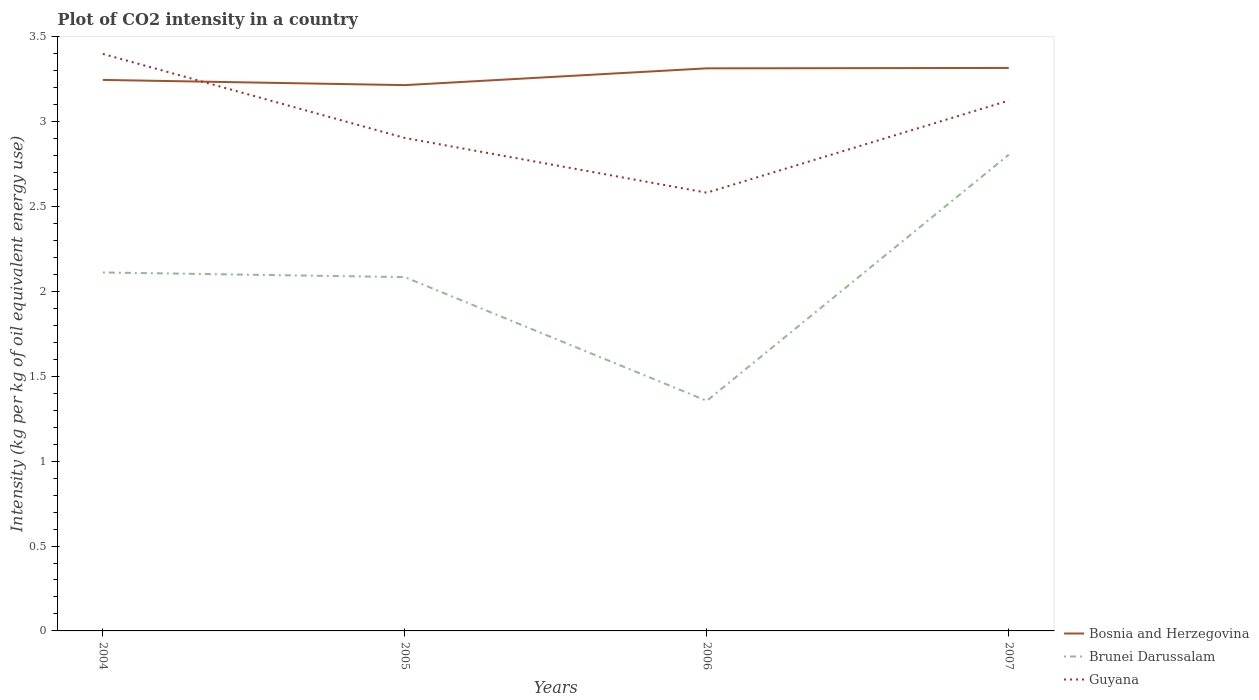How many different coloured lines are there?
Your answer should be compact. 3. Does the line corresponding to Brunei Darussalam intersect with the line corresponding to Bosnia and Herzegovina?
Provide a succinct answer. No. Is the number of lines equal to the number of legend labels?
Your answer should be compact. Yes. Across all years, what is the maximum CO2 intensity in in Brunei Darussalam?
Give a very brief answer. 1.36. What is the total CO2 intensity in in Guyana in the graph?
Offer a very short reply. 0.32. What is the difference between the highest and the second highest CO2 intensity in in Bosnia and Herzegovina?
Ensure brevity in your answer.  0.1. What is the difference between the highest and the lowest CO2 intensity in in Bosnia and Herzegovina?
Your answer should be very brief. 2. Does the graph contain any zero values?
Your response must be concise. No. Does the graph contain grids?
Make the answer very short. No. How many legend labels are there?
Offer a very short reply. 3. How are the legend labels stacked?
Offer a very short reply. Vertical. What is the title of the graph?
Give a very brief answer. Plot of CO2 intensity in a country. What is the label or title of the X-axis?
Offer a very short reply. Years. What is the label or title of the Y-axis?
Offer a terse response. Intensity (kg per kg of oil equivalent energy use). What is the Intensity (kg per kg of oil equivalent energy use) of Bosnia and Herzegovina in 2004?
Your answer should be compact. 3.25. What is the Intensity (kg per kg of oil equivalent energy use) of Brunei Darussalam in 2004?
Your answer should be compact. 2.11. What is the Intensity (kg per kg of oil equivalent energy use) in Guyana in 2004?
Provide a succinct answer. 3.4. What is the Intensity (kg per kg of oil equivalent energy use) of Bosnia and Herzegovina in 2005?
Offer a terse response. 3.22. What is the Intensity (kg per kg of oil equivalent energy use) in Brunei Darussalam in 2005?
Your answer should be compact. 2.08. What is the Intensity (kg per kg of oil equivalent energy use) in Guyana in 2005?
Offer a terse response. 2.9. What is the Intensity (kg per kg of oil equivalent energy use) of Bosnia and Herzegovina in 2006?
Provide a short and direct response. 3.31. What is the Intensity (kg per kg of oil equivalent energy use) of Brunei Darussalam in 2006?
Your answer should be very brief. 1.36. What is the Intensity (kg per kg of oil equivalent energy use) in Guyana in 2006?
Give a very brief answer. 2.58. What is the Intensity (kg per kg of oil equivalent energy use) in Bosnia and Herzegovina in 2007?
Your response must be concise. 3.32. What is the Intensity (kg per kg of oil equivalent energy use) of Brunei Darussalam in 2007?
Ensure brevity in your answer.  2.81. What is the Intensity (kg per kg of oil equivalent energy use) in Guyana in 2007?
Your answer should be very brief. 3.12. Across all years, what is the maximum Intensity (kg per kg of oil equivalent energy use) in Bosnia and Herzegovina?
Provide a short and direct response. 3.32. Across all years, what is the maximum Intensity (kg per kg of oil equivalent energy use) of Brunei Darussalam?
Make the answer very short. 2.81. Across all years, what is the maximum Intensity (kg per kg of oil equivalent energy use) of Guyana?
Your response must be concise. 3.4. Across all years, what is the minimum Intensity (kg per kg of oil equivalent energy use) of Bosnia and Herzegovina?
Give a very brief answer. 3.22. Across all years, what is the minimum Intensity (kg per kg of oil equivalent energy use) in Brunei Darussalam?
Keep it short and to the point. 1.36. Across all years, what is the minimum Intensity (kg per kg of oil equivalent energy use) in Guyana?
Give a very brief answer. 2.58. What is the total Intensity (kg per kg of oil equivalent energy use) of Bosnia and Herzegovina in the graph?
Provide a succinct answer. 13.09. What is the total Intensity (kg per kg of oil equivalent energy use) in Brunei Darussalam in the graph?
Your response must be concise. 8.36. What is the total Intensity (kg per kg of oil equivalent energy use) of Guyana in the graph?
Your response must be concise. 12.01. What is the difference between the Intensity (kg per kg of oil equivalent energy use) in Bosnia and Herzegovina in 2004 and that in 2005?
Keep it short and to the point. 0.03. What is the difference between the Intensity (kg per kg of oil equivalent energy use) in Brunei Darussalam in 2004 and that in 2005?
Make the answer very short. 0.03. What is the difference between the Intensity (kg per kg of oil equivalent energy use) of Guyana in 2004 and that in 2005?
Offer a terse response. 0.5. What is the difference between the Intensity (kg per kg of oil equivalent energy use) in Bosnia and Herzegovina in 2004 and that in 2006?
Your answer should be compact. -0.07. What is the difference between the Intensity (kg per kg of oil equivalent energy use) of Brunei Darussalam in 2004 and that in 2006?
Provide a short and direct response. 0.76. What is the difference between the Intensity (kg per kg of oil equivalent energy use) in Guyana in 2004 and that in 2006?
Provide a short and direct response. 0.82. What is the difference between the Intensity (kg per kg of oil equivalent energy use) of Bosnia and Herzegovina in 2004 and that in 2007?
Provide a succinct answer. -0.07. What is the difference between the Intensity (kg per kg of oil equivalent energy use) of Brunei Darussalam in 2004 and that in 2007?
Provide a succinct answer. -0.69. What is the difference between the Intensity (kg per kg of oil equivalent energy use) of Guyana in 2004 and that in 2007?
Give a very brief answer. 0.27. What is the difference between the Intensity (kg per kg of oil equivalent energy use) in Bosnia and Herzegovina in 2005 and that in 2006?
Your answer should be very brief. -0.1. What is the difference between the Intensity (kg per kg of oil equivalent energy use) in Brunei Darussalam in 2005 and that in 2006?
Offer a terse response. 0.73. What is the difference between the Intensity (kg per kg of oil equivalent energy use) in Guyana in 2005 and that in 2006?
Give a very brief answer. 0.32. What is the difference between the Intensity (kg per kg of oil equivalent energy use) in Bosnia and Herzegovina in 2005 and that in 2007?
Your response must be concise. -0.1. What is the difference between the Intensity (kg per kg of oil equivalent energy use) in Brunei Darussalam in 2005 and that in 2007?
Provide a short and direct response. -0.72. What is the difference between the Intensity (kg per kg of oil equivalent energy use) in Guyana in 2005 and that in 2007?
Keep it short and to the point. -0.22. What is the difference between the Intensity (kg per kg of oil equivalent energy use) of Bosnia and Herzegovina in 2006 and that in 2007?
Offer a very short reply. -0. What is the difference between the Intensity (kg per kg of oil equivalent energy use) in Brunei Darussalam in 2006 and that in 2007?
Offer a very short reply. -1.45. What is the difference between the Intensity (kg per kg of oil equivalent energy use) of Guyana in 2006 and that in 2007?
Ensure brevity in your answer.  -0.54. What is the difference between the Intensity (kg per kg of oil equivalent energy use) in Bosnia and Herzegovina in 2004 and the Intensity (kg per kg of oil equivalent energy use) in Brunei Darussalam in 2005?
Provide a short and direct response. 1.16. What is the difference between the Intensity (kg per kg of oil equivalent energy use) of Bosnia and Herzegovina in 2004 and the Intensity (kg per kg of oil equivalent energy use) of Guyana in 2005?
Offer a very short reply. 0.34. What is the difference between the Intensity (kg per kg of oil equivalent energy use) in Brunei Darussalam in 2004 and the Intensity (kg per kg of oil equivalent energy use) in Guyana in 2005?
Ensure brevity in your answer.  -0.79. What is the difference between the Intensity (kg per kg of oil equivalent energy use) in Bosnia and Herzegovina in 2004 and the Intensity (kg per kg of oil equivalent energy use) in Brunei Darussalam in 2006?
Give a very brief answer. 1.89. What is the difference between the Intensity (kg per kg of oil equivalent energy use) of Bosnia and Herzegovina in 2004 and the Intensity (kg per kg of oil equivalent energy use) of Guyana in 2006?
Keep it short and to the point. 0.66. What is the difference between the Intensity (kg per kg of oil equivalent energy use) in Brunei Darussalam in 2004 and the Intensity (kg per kg of oil equivalent energy use) in Guyana in 2006?
Your response must be concise. -0.47. What is the difference between the Intensity (kg per kg of oil equivalent energy use) of Bosnia and Herzegovina in 2004 and the Intensity (kg per kg of oil equivalent energy use) of Brunei Darussalam in 2007?
Give a very brief answer. 0.44. What is the difference between the Intensity (kg per kg of oil equivalent energy use) of Bosnia and Herzegovina in 2004 and the Intensity (kg per kg of oil equivalent energy use) of Guyana in 2007?
Your answer should be compact. 0.12. What is the difference between the Intensity (kg per kg of oil equivalent energy use) of Brunei Darussalam in 2004 and the Intensity (kg per kg of oil equivalent energy use) of Guyana in 2007?
Make the answer very short. -1.01. What is the difference between the Intensity (kg per kg of oil equivalent energy use) in Bosnia and Herzegovina in 2005 and the Intensity (kg per kg of oil equivalent energy use) in Brunei Darussalam in 2006?
Give a very brief answer. 1.86. What is the difference between the Intensity (kg per kg of oil equivalent energy use) of Bosnia and Herzegovina in 2005 and the Intensity (kg per kg of oil equivalent energy use) of Guyana in 2006?
Your answer should be very brief. 0.63. What is the difference between the Intensity (kg per kg of oil equivalent energy use) in Brunei Darussalam in 2005 and the Intensity (kg per kg of oil equivalent energy use) in Guyana in 2006?
Ensure brevity in your answer.  -0.5. What is the difference between the Intensity (kg per kg of oil equivalent energy use) in Bosnia and Herzegovina in 2005 and the Intensity (kg per kg of oil equivalent energy use) in Brunei Darussalam in 2007?
Provide a short and direct response. 0.41. What is the difference between the Intensity (kg per kg of oil equivalent energy use) in Bosnia and Herzegovina in 2005 and the Intensity (kg per kg of oil equivalent energy use) in Guyana in 2007?
Provide a short and direct response. 0.09. What is the difference between the Intensity (kg per kg of oil equivalent energy use) in Brunei Darussalam in 2005 and the Intensity (kg per kg of oil equivalent energy use) in Guyana in 2007?
Give a very brief answer. -1.04. What is the difference between the Intensity (kg per kg of oil equivalent energy use) of Bosnia and Herzegovina in 2006 and the Intensity (kg per kg of oil equivalent energy use) of Brunei Darussalam in 2007?
Make the answer very short. 0.51. What is the difference between the Intensity (kg per kg of oil equivalent energy use) of Bosnia and Herzegovina in 2006 and the Intensity (kg per kg of oil equivalent energy use) of Guyana in 2007?
Provide a short and direct response. 0.19. What is the difference between the Intensity (kg per kg of oil equivalent energy use) of Brunei Darussalam in 2006 and the Intensity (kg per kg of oil equivalent energy use) of Guyana in 2007?
Your answer should be very brief. -1.77. What is the average Intensity (kg per kg of oil equivalent energy use) of Bosnia and Herzegovina per year?
Your answer should be compact. 3.27. What is the average Intensity (kg per kg of oil equivalent energy use) in Brunei Darussalam per year?
Make the answer very short. 2.09. What is the average Intensity (kg per kg of oil equivalent energy use) in Guyana per year?
Offer a very short reply. 3. In the year 2004, what is the difference between the Intensity (kg per kg of oil equivalent energy use) of Bosnia and Herzegovina and Intensity (kg per kg of oil equivalent energy use) of Brunei Darussalam?
Your answer should be compact. 1.13. In the year 2004, what is the difference between the Intensity (kg per kg of oil equivalent energy use) of Bosnia and Herzegovina and Intensity (kg per kg of oil equivalent energy use) of Guyana?
Give a very brief answer. -0.15. In the year 2004, what is the difference between the Intensity (kg per kg of oil equivalent energy use) in Brunei Darussalam and Intensity (kg per kg of oil equivalent energy use) in Guyana?
Keep it short and to the point. -1.29. In the year 2005, what is the difference between the Intensity (kg per kg of oil equivalent energy use) in Bosnia and Herzegovina and Intensity (kg per kg of oil equivalent energy use) in Brunei Darussalam?
Keep it short and to the point. 1.13. In the year 2005, what is the difference between the Intensity (kg per kg of oil equivalent energy use) in Bosnia and Herzegovina and Intensity (kg per kg of oil equivalent energy use) in Guyana?
Your answer should be very brief. 0.31. In the year 2005, what is the difference between the Intensity (kg per kg of oil equivalent energy use) of Brunei Darussalam and Intensity (kg per kg of oil equivalent energy use) of Guyana?
Provide a short and direct response. -0.82. In the year 2006, what is the difference between the Intensity (kg per kg of oil equivalent energy use) of Bosnia and Herzegovina and Intensity (kg per kg of oil equivalent energy use) of Brunei Darussalam?
Your answer should be compact. 1.96. In the year 2006, what is the difference between the Intensity (kg per kg of oil equivalent energy use) in Bosnia and Herzegovina and Intensity (kg per kg of oil equivalent energy use) in Guyana?
Offer a very short reply. 0.73. In the year 2006, what is the difference between the Intensity (kg per kg of oil equivalent energy use) in Brunei Darussalam and Intensity (kg per kg of oil equivalent energy use) in Guyana?
Your response must be concise. -1.23. In the year 2007, what is the difference between the Intensity (kg per kg of oil equivalent energy use) in Bosnia and Herzegovina and Intensity (kg per kg of oil equivalent energy use) in Brunei Darussalam?
Your response must be concise. 0.51. In the year 2007, what is the difference between the Intensity (kg per kg of oil equivalent energy use) of Bosnia and Herzegovina and Intensity (kg per kg of oil equivalent energy use) of Guyana?
Keep it short and to the point. 0.19. In the year 2007, what is the difference between the Intensity (kg per kg of oil equivalent energy use) of Brunei Darussalam and Intensity (kg per kg of oil equivalent energy use) of Guyana?
Your answer should be compact. -0.32. What is the ratio of the Intensity (kg per kg of oil equivalent energy use) of Bosnia and Herzegovina in 2004 to that in 2005?
Ensure brevity in your answer.  1.01. What is the ratio of the Intensity (kg per kg of oil equivalent energy use) in Brunei Darussalam in 2004 to that in 2005?
Keep it short and to the point. 1.01. What is the ratio of the Intensity (kg per kg of oil equivalent energy use) of Guyana in 2004 to that in 2005?
Offer a very short reply. 1.17. What is the ratio of the Intensity (kg per kg of oil equivalent energy use) of Bosnia and Herzegovina in 2004 to that in 2006?
Provide a short and direct response. 0.98. What is the ratio of the Intensity (kg per kg of oil equivalent energy use) in Brunei Darussalam in 2004 to that in 2006?
Your answer should be compact. 1.56. What is the ratio of the Intensity (kg per kg of oil equivalent energy use) in Guyana in 2004 to that in 2006?
Your answer should be very brief. 1.32. What is the ratio of the Intensity (kg per kg of oil equivalent energy use) of Bosnia and Herzegovina in 2004 to that in 2007?
Give a very brief answer. 0.98. What is the ratio of the Intensity (kg per kg of oil equivalent energy use) in Brunei Darussalam in 2004 to that in 2007?
Your response must be concise. 0.75. What is the ratio of the Intensity (kg per kg of oil equivalent energy use) of Guyana in 2004 to that in 2007?
Your response must be concise. 1.09. What is the ratio of the Intensity (kg per kg of oil equivalent energy use) of Bosnia and Herzegovina in 2005 to that in 2006?
Provide a succinct answer. 0.97. What is the ratio of the Intensity (kg per kg of oil equivalent energy use) of Brunei Darussalam in 2005 to that in 2006?
Provide a succinct answer. 1.54. What is the ratio of the Intensity (kg per kg of oil equivalent energy use) in Guyana in 2005 to that in 2006?
Provide a succinct answer. 1.12. What is the ratio of the Intensity (kg per kg of oil equivalent energy use) of Bosnia and Herzegovina in 2005 to that in 2007?
Your answer should be very brief. 0.97. What is the ratio of the Intensity (kg per kg of oil equivalent energy use) in Brunei Darussalam in 2005 to that in 2007?
Your answer should be very brief. 0.74. What is the ratio of the Intensity (kg per kg of oil equivalent energy use) in Guyana in 2005 to that in 2007?
Keep it short and to the point. 0.93. What is the ratio of the Intensity (kg per kg of oil equivalent energy use) in Bosnia and Herzegovina in 2006 to that in 2007?
Give a very brief answer. 1. What is the ratio of the Intensity (kg per kg of oil equivalent energy use) in Brunei Darussalam in 2006 to that in 2007?
Give a very brief answer. 0.48. What is the ratio of the Intensity (kg per kg of oil equivalent energy use) in Guyana in 2006 to that in 2007?
Your answer should be very brief. 0.83. What is the difference between the highest and the second highest Intensity (kg per kg of oil equivalent energy use) of Bosnia and Herzegovina?
Ensure brevity in your answer.  0. What is the difference between the highest and the second highest Intensity (kg per kg of oil equivalent energy use) in Brunei Darussalam?
Offer a terse response. 0.69. What is the difference between the highest and the second highest Intensity (kg per kg of oil equivalent energy use) in Guyana?
Give a very brief answer. 0.27. What is the difference between the highest and the lowest Intensity (kg per kg of oil equivalent energy use) of Bosnia and Herzegovina?
Offer a very short reply. 0.1. What is the difference between the highest and the lowest Intensity (kg per kg of oil equivalent energy use) of Brunei Darussalam?
Your response must be concise. 1.45. What is the difference between the highest and the lowest Intensity (kg per kg of oil equivalent energy use) of Guyana?
Provide a succinct answer. 0.82. 